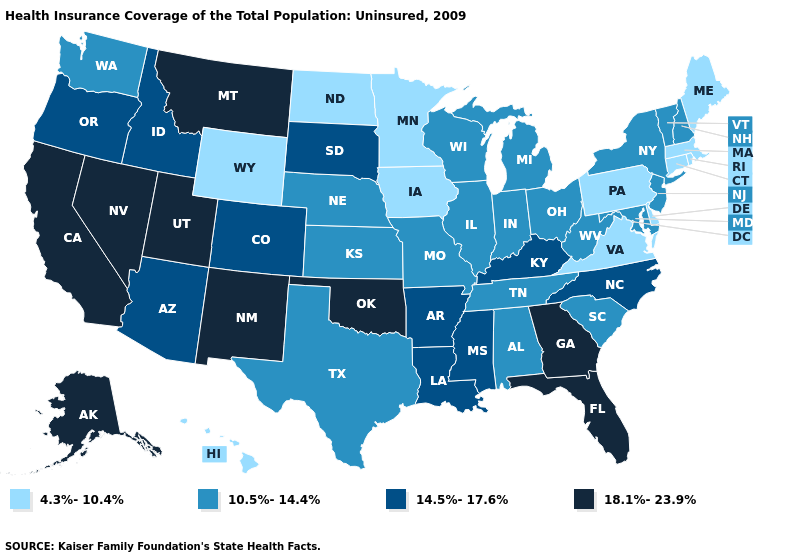Does Maryland have the highest value in the USA?
Short answer required. No. What is the highest value in the USA?
Concise answer only. 18.1%-23.9%. Among the states that border Minnesota , which have the lowest value?
Short answer required. Iowa, North Dakota. What is the highest value in the MidWest ?
Concise answer only. 14.5%-17.6%. Name the states that have a value in the range 14.5%-17.6%?
Concise answer only. Arizona, Arkansas, Colorado, Idaho, Kentucky, Louisiana, Mississippi, North Carolina, Oregon, South Dakota. What is the lowest value in the South?
Be succinct. 4.3%-10.4%. Name the states that have a value in the range 14.5%-17.6%?
Answer briefly. Arizona, Arkansas, Colorado, Idaho, Kentucky, Louisiana, Mississippi, North Carolina, Oregon, South Dakota. Name the states that have a value in the range 4.3%-10.4%?
Quick response, please. Connecticut, Delaware, Hawaii, Iowa, Maine, Massachusetts, Minnesota, North Dakota, Pennsylvania, Rhode Island, Virginia, Wyoming. Name the states that have a value in the range 10.5%-14.4%?
Concise answer only. Alabama, Illinois, Indiana, Kansas, Maryland, Michigan, Missouri, Nebraska, New Hampshire, New Jersey, New York, Ohio, South Carolina, Tennessee, Texas, Vermont, Washington, West Virginia, Wisconsin. What is the value of Nebraska?
Answer briefly. 10.5%-14.4%. Among the states that border Iowa , which have the highest value?
Quick response, please. South Dakota. Which states have the highest value in the USA?
Keep it brief. Alaska, California, Florida, Georgia, Montana, Nevada, New Mexico, Oklahoma, Utah. Does the first symbol in the legend represent the smallest category?
Answer briefly. Yes. What is the lowest value in states that border New Hampshire?
Quick response, please. 4.3%-10.4%. What is the value of Washington?
Give a very brief answer. 10.5%-14.4%. 